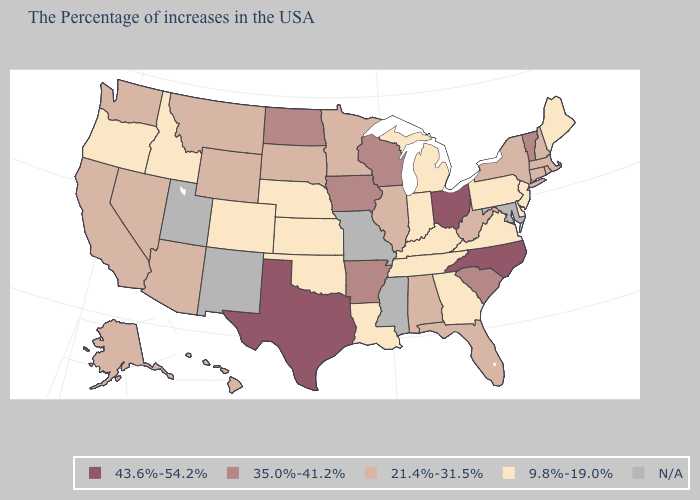Which states have the highest value in the USA?
Give a very brief answer. North Carolina, Ohio, Texas. What is the value of Kansas?
Give a very brief answer. 9.8%-19.0%. Which states have the highest value in the USA?
Be succinct. North Carolina, Ohio, Texas. What is the value of Ohio?
Short answer required. 43.6%-54.2%. What is the value of Washington?
Be succinct. 21.4%-31.5%. What is the lowest value in the MidWest?
Write a very short answer. 9.8%-19.0%. Which states have the highest value in the USA?
Answer briefly. North Carolina, Ohio, Texas. What is the value of California?
Write a very short answer. 21.4%-31.5%. Among the states that border Alabama , does Florida have the lowest value?
Be succinct. No. Is the legend a continuous bar?
Give a very brief answer. No. Among the states that border South Carolina , does North Carolina have the highest value?
Be succinct. Yes. What is the value of North Dakota?
Keep it brief. 35.0%-41.2%. What is the value of Rhode Island?
Be succinct. 21.4%-31.5%. 